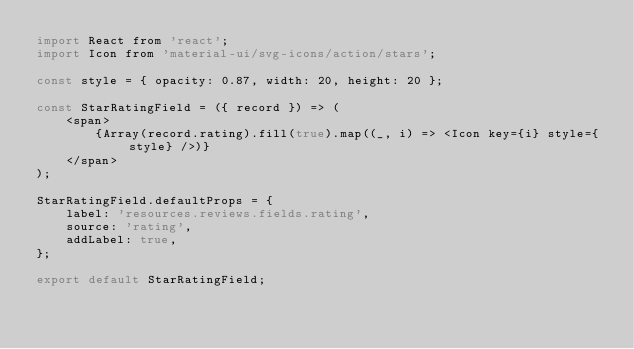<code> <loc_0><loc_0><loc_500><loc_500><_JavaScript_>import React from 'react';
import Icon from 'material-ui/svg-icons/action/stars';

const style = { opacity: 0.87, width: 20, height: 20 };

const StarRatingField = ({ record }) => (
    <span>
        {Array(record.rating).fill(true).map((_, i) => <Icon key={i} style={style} />)}
    </span>
);

StarRatingField.defaultProps = {
    label: 'resources.reviews.fields.rating',
    source: 'rating',
    addLabel: true,
};

export default StarRatingField;
</code> 